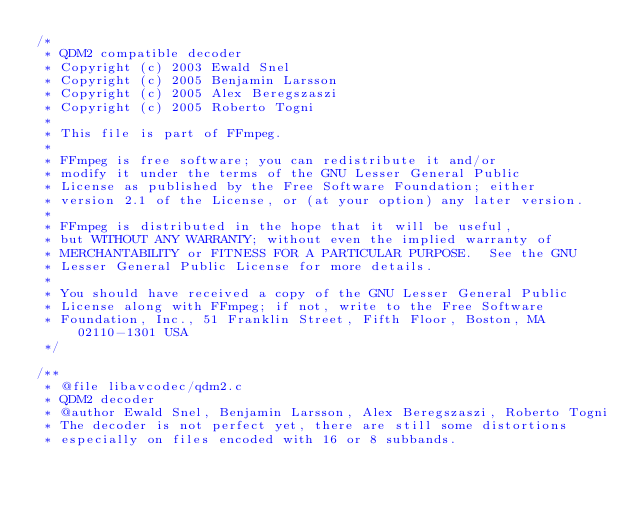Convert code to text. <code><loc_0><loc_0><loc_500><loc_500><_C_>/*
 * QDM2 compatible decoder
 * Copyright (c) 2003 Ewald Snel
 * Copyright (c) 2005 Benjamin Larsson
 * Copyright (c) 2005 Alex Beregszaszi
 * Copyright (c) 2005 Roberto Togni
 *
 * This file is part of FFmpeg.
 *
 * FFmpeg is free software; you can redistribute it and/or
 * modify it under the terms of the GNU Lesser General Public
 * License as published by the Free Software Foundation; either
 * version 2.1 of the License, or (at your option) any later version.
 *
 * FFmpeg is distributed in the hope that it will be useful,
 * but WITHOUT ANY WARRANTY; without even the implied warranty of
 * MERCHANTABILITY or FITNESS FOR A PARTICULAR PURPOSE.  See the GNU
 * Lesser General Public License for more details.
 *
 * You should have received a copy of the GNU Lesser General Public
 * License along with FFmpeg; if not, write to the Free Software
 * Foundation, Inc., 51 Franklin Street, Fifth Floor, Boston, MA 02110-1301 USA
 */

/**
 * @file libavcodec/qdm2.c
 * QDM2 decoder
 * @author Ewald Snel, Benjamin Larsson, Alex Beregszaszi, Roberto Togni
 * The decoder is not perfect yet, there are still some distortions
 * especially on files encoded with 16 or 8 subbands.</code> 